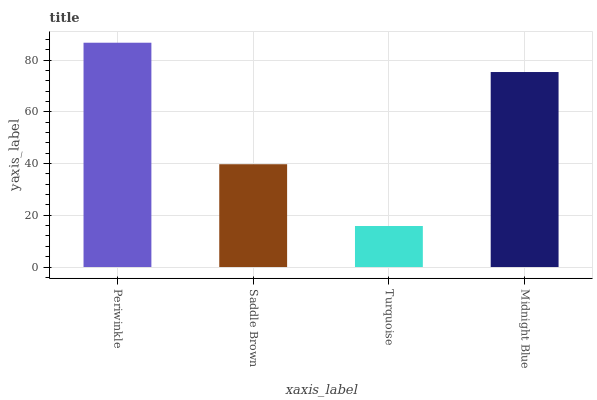Is Turquoise the minimum?
Answer yes or no. Yes. Is Periwinkle the maximum?
Answer yes or no. Yes. Is Saddle Brown the minimum?
Answer yes or no. No. Is Saddle Brown the maximum?
Answer yes or no. No. Is Periwinkle greater than Saddle Brown?
Answer yes or no. Yes. Is Saddle Brown less than Periwinkle?
Answer yes or no. Yes. Is Saddle Brown greater than Periwinkle?
Answer yes or no. No. Is Periwinkle less than Saddle Brown?
Answer yes or no. No. Is Midnight Blue the high median?
Answer yes or no. Yes. Is Saddle Brown the low median?
Answer yes or no. Yes. Is Saddle Brown the high median?
Answer yes or no. No. Is Midnight Blue the low median?
Answer yes or no. No. 